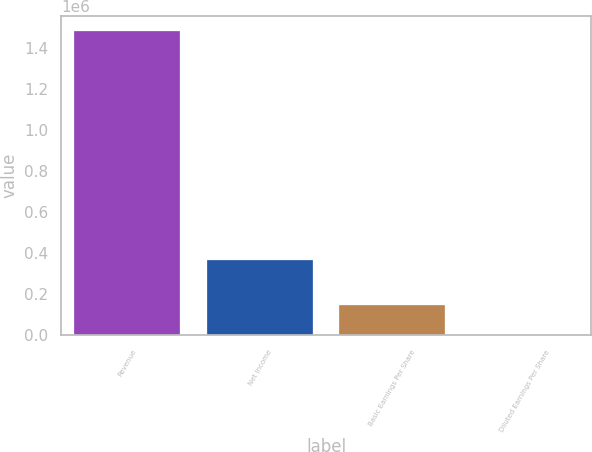<chart> <loc_0><loc_0><loc_500><loc_500><bar_chart><fcel>Revenue<fcel>Net Income<fcel>Basic Earnings Per Share<fcel>Diluted Earnings Per Share<nl><fcel>1.48392e+06<fcel>366544<fcel>148396<fcel>4.72<nl></chart> 